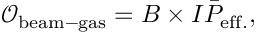Convert formula to latex. <formula><loc_0><loc_0><loc_500><loc_500>\mathcal { O } _ { b e a m - g a s } = B \times I \bar { P } _ { e f f . } ,</formula> 